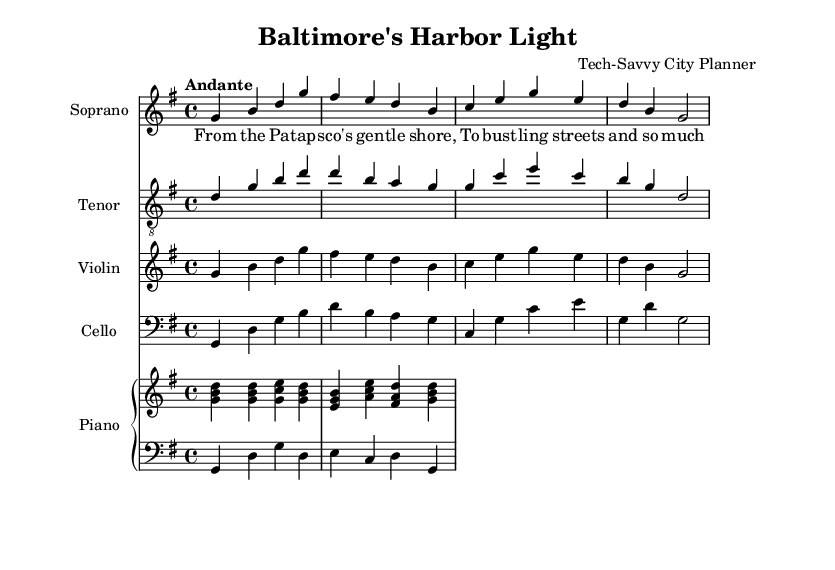What is the key signature of this music? The key signature is G major, which has one sharp (F#). This is determined from the key signature indicated in the global section of the code.
Answer: G major What is the time signature of this piece? The time signature is 4/4, meaning there are four beats per measure. This is indicated in the global section of the code.
Answer: 4/4 What is the tempo marking given in the score? The tempo marking is "Andante", suggesting a moderately slow tempo. It is directly stated in the tempo section of the global configuration.
Answer: Andante How many voices are present in the sheet music? There are four voices present: soprano, tenor, violin, and cello. This is identified by the different staves and parts indicated in the score.
Answer: Four What type of song structure is used in this opera excerpt? The opera excerpt uses lyrical verses accompanied by instrumental parts, typical of operatic music. This can be determined by the presence of lyrics assigned to the soprano voice and the accompanying instrumental parts.
Answer: Lyrical verses Which instrument has the lowest range in this arrangement? The cello has the lowest range, as indicated by its placement in the bass clef and the lowest notes played in the music.
Answer: Cello What is the dynamic marking for the soprano voice? The dynamic marking is "Up", indicating that the dynamics for the soprano voice are meant to be played with an ascending emphasis. This can be seen in the voice's dynamic notation.
Answer: Up 